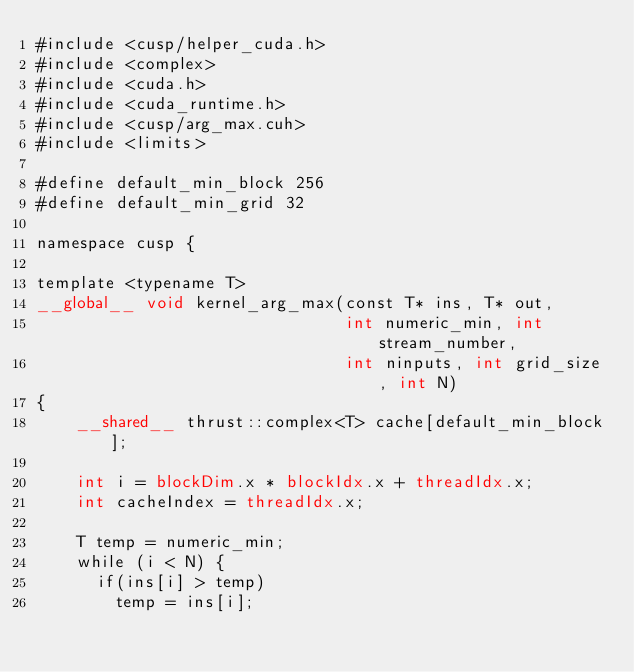<code> <loc_0><loc_0><loc_500><loc_500><_Cuda_>#include <cusp/helper_cuda.h>
#include <complex>
#include <cuda.h>
#include <cuda_runtime.h>
#include <cusp/arg_max.cuh>
#include <limits>

#define default_min_block 256
#define default_min_grid 32

namespace cusp {

template <typename T>
__global__ void kernel_arg_max(const T* ins, T* out,
                               int numeric_min, int stream_number,
                               int ninputs, int grid_size, int N)
{
    __shared__ thrust::complex<T> cache[default_min_block];

    int i = blockDim.x * blockIdx.x + threadIdx.x;
    int cacheIndex = threadIdx.x;

    T temp = numeric_min;
    while (i < N) {
    	if(ins[i] > temp)
    		temp = ins[i];</code> 